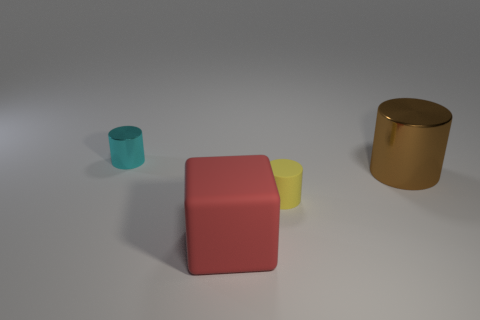There is a small thing that is behind the tiny cylinder that is in front of the big metallic cylinder; are there any tiny cyan metal objects on the right side of it?
Ensure brevity in your answer.  No. There is a large brown object; what number of tiny cyan cylinders are to the left of it?
Offer a terse response. 1. How many matte cubes have the same color as the tiny matte cylinder?
Your response must be concise. 0. What number of objects are things to the left of the block or metallic cylinders behind the large cylinder?
Your answer should be very brief. 1. Are there more small red matte objects than cyan metallic cylinders?
Provide a succinct answer. No. There is a tiny object that is behind the brown object; what is its color?
Offer a terse response. Cyan. Does the brown metal thing have the same shape as the cyan object?
Make the answer very short. Yes. What color is the object that is both left of the matte cylinder and in front of the cyan shiny object?
Keep it short and to the point. Red. There is a metallic cylinder that is behind the brown metal cylinder; does it have the same size as the shiny cylinder that is in front of the cyan metallic thing?
Your answer should be compact. No. What number of objects are cylinders to the left of the red matte cube or metallic things?
Offer a terse response. 2. 